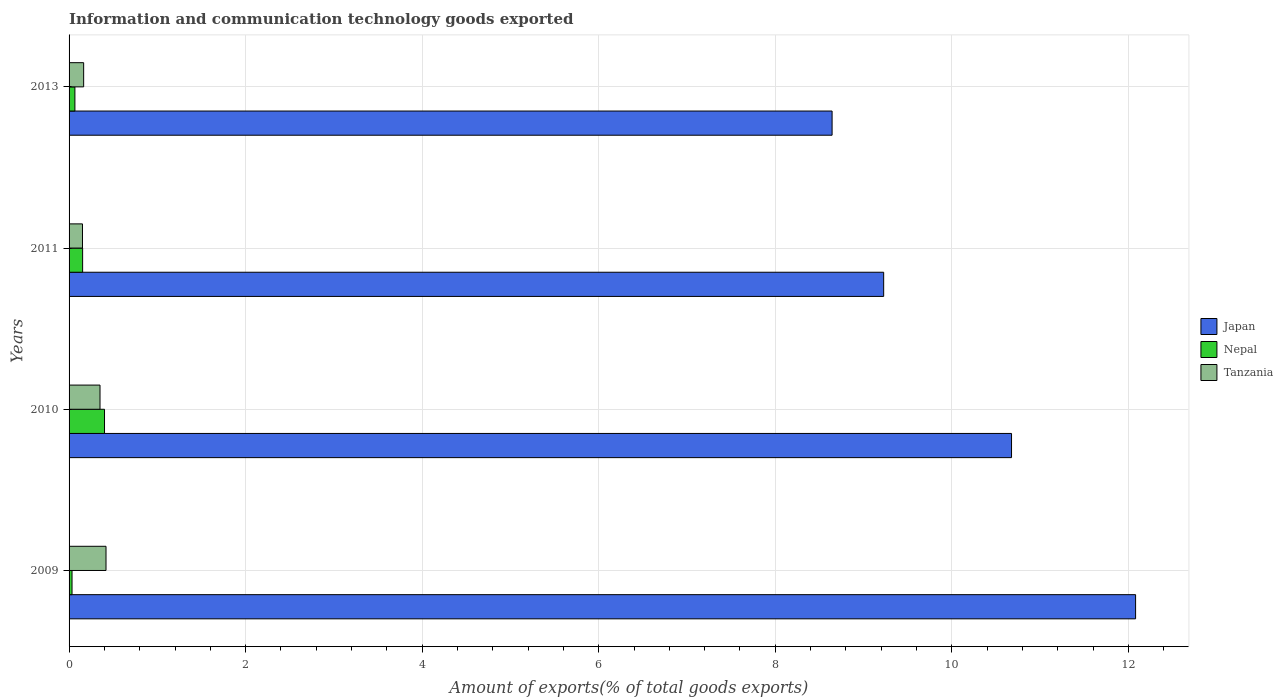How many groups of bars are there?
Provide a succinct answer. 4. Are the number of bars on each tick of the Y-axis equal?
Provide a succinct answer. Yes. How many bars are there on the 3rd tick from the top?
Keep it short and to the point. 3. How many bars are there on the 4th tick from the bottom?
Offer a terse response. 3. In how many cases, is the number of bars for a given year not equal to the number of legend labels?
Make the answer very short. 0. What is the amount of goods exported in Nepal in 2011?
Your answer should be very brief. 0.15. Across all years, what is the maximum amount of goods exported in Tanzania?
Your answer should be very brief. 0.42. Across all years, what is the minimum amount of goods exported in Nepal?
Your answer should be very brief. 0.03. In which year was the amount of goods exported in Tanzania maximum?
Offer a very short reply. 2009. What is the total amount of goods exported in Tanzania in the graph?
Give a very brief answer. 1.09. What is the difference between the amount of goods exported in Japan in 2009 and that in 2013?
Your answer should be compact. 3.44. What is the difference between the amount of goods exported in Japan in 2009 and the amount of goods exported in Nepal in 2011?
Make the answer very short. 11.93. What is the average amount of goods exported in Tanzania per year?
Your answer should be very brief. 0.27. In the year 2011, what is the difference between the amount of goods exported in Tanzania and amount of goods exported in Nepal?
Keep it short and to the point. -0. What is the ratio of the amount of goods exported in Japan in 2010 to that in 2013?
Keep it short and to the point. 1.24. Is the amount of goods exported in Japan in 2009 less than that in 2011?
Offer a terse response. No. What is the difference between the highest and the second highest amount of goods exported in Japan?
Your answer should be very brief. 1.41. What is the difference between the highest and the lowest amount of goods exported in Nepal?
Ensure brevity in your answer.  0.37. What does the 3rd bar from the top in 2010 represents?
Ensure brevity in your answer.  Japan. How many bars are there?
Offer a very short reply. 12. Are the values on the major ticks of X-axis written in scientific E-notation?
Keep it short and to the point. No. Does the graph contain any zero values?
Ensure brevity in your answer.  No. How are the legend labels stacked?
Ensure brevity in your answer.  Vertical. What is the title of the graph?
Your response must be concise. Information and communication technology goods exported. What is the label or title of the X-axis?
Provide a succinct answer. Amount of exports(% of total goods exports). What is the label or title of the Y-axis?
Provide a succinct answer. Years. What is the Amount of exports(% of total goods exports) of Japan in 2009?
Provide a short and direct response. 12.08. What is the Amount of exports(% of total goods exports) of Nepal in 2009?
Offer a very short reply. 0.03. What is the Amount of exports(% of total goods exports) of Tanzania in 2009?
Your answer should be compact. 0.42. What is the Amount of exports(% of total goods exports) in Japan in 2010?
Ensure brevity in your answer.  10.68. What is the Amount of exports(% of total goods exports) in Nepal in 2010?
Your answer should be compact. 0.4. What is the Amount of exports(% of total goods exports) of Tanzania in 2010?
Your answer should be very brief. 0.35. What is the Amount of exports(% of total goods exports) in Japan in 2011?
Offer a terse response. 9.23. What is the Amount of exports(% of total goods exports) in Nepal in 2011?
Your answer should be very brief. 0.15. What is the Amount of exports(% of total goods exports) of Tanzania in 2011?
Provide a succinct answer. 0.15. What is the Amount of exports(% of total goods exports) in Japan in 2013?
Ensure brevity in your answer.  8.64. What is the Amount of exports(% of total goods exports) of Nepal in 2013?
Your answer should be compact. 0.07. What is the Amount of exports(% of total goods exports) of Tanzania in 2013?
Offer a terse response. 0.17. Across all years, what is the maximum Amount of exports(% of total goods exports) in Japan?
Give a very brief answer. 12.08. Across all years, what is the maximum Amount of exports(% of total goods exports) of Nepal?
Provide a succinct answer. 0.4. Across all years, what is the maximum Amount of exports(% of total goods exports) of Tanzania?
Give a very brief answer. 0.42. Across all years, what is the minimum Amount of exports(% of total goods exports) in Japan?
Provide a succinct answer. 8.64. Across all years, what is the minimum Amount of exports(% of total goods exports) of Nepal?
Provide a short and direct response. 0.03. Across all years, what is the minimum Amount of exports(% of total goods exports) in Tanzania?
Provide a short and direct response. 0.15. What is the total Amount of exports(% of total goods exports) in Japan in the graph?
Provide a succinct answer. 40.63. What is the total Amount of exports(% of total goods exports) of Nepal in the graph?
Keep it short and to the point. 0.65. What is the total Amount of exports(% of total goods exports) in Tanzania in the graph?
Provide a succinct answer. 1.09. What is the difference between the Amount of exports(% of total goods exports) in Japan in 2009 and that in 2010?
Your answer should be very brief. 1.41. What is the difference between the Amount of exports(% of total goods exports) in Nepal in 2009 and that in 2010?
Keep it short and to the point. -0.37. What is the difference between the Amount of exports(% of total goods exports) of Tanzania in 2009 and that in 2010?
Ensure brevity in your answer.  0.07. What is the difference between the Amount of exports(% of total goods exports) in Japan in 2009 and that in 2011?
Keep it short and to the point. 2.85. What is the difference between the Amount of exports(% of total goods exports) in Nepal in 2009 and that in 2011?
Your answer should be very brief. -0.12. What is the difference between the Amount of exports(% of total goods exports) of Tanzania in 2009 and that in 2011?
Your answer should be very brief. 0.27. What is the difference between the Amount of exports(% of total goods exports) of Japan in 2009 and that in 2013?
Provide a succinct answer. 3.44. What is the difference between the Amount of exports(% of total goods exports) of Nepal in 2009 and that in 2013?
Keep it short and to the point. -0.03. What is the difference between the Amount of exports(% of total goods exports) of Tanzania in 2009 and that in 2013?
Provide a succinct answer. 0.25. What is the difference between the Amount of exports(% of total goods exports) in Japan in 2010 and that in 2011?
Give a very brief answer. 1.45. What is the difference between the Amount of exports(% of total goods exports) of Nepal in 2010 and that in 2011?
Give a very brief answer. 0.25. What is the difference between the Amount of exports(% of total goods exports) in Tanzania in 2010 and that in 2011?
Your response must be concise. 0.2. What is the difference between the Amount of exports(% of total goods exports) of Japan in 2010 and that in 2013?
Offer a terse response. 2.03. What is the difference between the Amount of exports(% of total goods exports) in Nepal in 2010 and that in 2013?
Offer a very short reply. 0.34. What is the difference between the Amount of exports(% of total goods exports) in Tanzania in 2010 and that in 2013?
Give a very brief answer. 0.19. What is the difference between the Amount of exports(% of total goods exports) in Japan in 2011 and that in 2013?
Give a very brief answer. 0.58. What is the difference between the Amount of exports(% of total goods exports) in Nepal in 2011 and that in 2013?
Offer a terse response. 0.09. What is the difference between the Amount of exports(% of total goods exports) of Tanzania in 2011 and that in 2013?
Make the answer very short. -0.01. What is the difference between the Amount of exports(% of total goods exports) of Japan in 2009 and the Amount of exports(% of total goods exports) of Nepal in 2010?
Offer a terse response. 11.68. What is the difference between the Amount of exports(% of total goods exports) of Japan in 2009 and the Amount of exports(% of total goods exports) of Tanzania in 2010?
Your answer should be very brief. 11.73. What is the difference between the Amount of exports(% of total goods exports) of Nepal in 2009 and the Amount of exports(% of total goods exports) of Tanzania in 2010?
Ensure brevity in your answer.  -0.32. What is the difference between the Amount of exports(% of total goods exports) in Japan in 2009 and the Amount of exports(% of total goods exports) in Nepal in 2011?
Your answer should be very brief. 11.93. What is the difference between the Amount of exports(% of total goods exports) of Japan in 2009 and the Amount of exports(% of total goods exports) of Tanzania in 2011?
Keep it short and to the point. 11.93. What is the difference between the Amount of exports(% of total goods exports) in Nepal in 2009 and the Amount of exports(% of total goods exports) in Tanzania in 2011?
Ensure brevity in your answer.  -0.12. What is the difference between the Amount of exports(% of total goods exports) of Japan in 2009 and the Amount of exports(% of total goods exports) of Nepal in 2013?
Provide a short and direct response. 12.02. What is the difference between the Amount of exports(% of total goods exports) of Japan in 2009 and the Amount of exports(% of total goods exports) of Tanzania in 2013?
Your answer should be compact. 11.92. What is the difference between the Amount of exports(% of total goods exports) in Nepal in 2009 and the Amount of exports(% of total goods exports) in Tanzania in 2013?
Offer a very short reply. -0.13. What is the difference between the Amount of exports(% of total goods exports) of Japan in 2010 and the Amount of exports(% of total goods exports) of Nepal in 2011?
Your answer should be compact. 10.52. What is the difference between the Amount of exports(% of total goods exports) in Japan in 2010 and the Amount of exports(% of total goods exports) in Tanzania in 2011?
Provide a short and direct response. 10.52. What is the difference between the Amount of exports(% of total goods exports) in Nepal in 2010 and the Amount of exports(% of total goods exports) in Tanzania in 2011?
Provide a short and direct response. 0.25. What is the difference between the Amount of exports(% of total goods exports) of Japan in 2010 and the Amount of exports(% of total goods exports) of Nepal in 2013?
Your answer should be compact. 10.61. What is the difference between the Amount of exports(% of total goods exports) of Japan in 2010 and the Amount of exports(% of total goods exports) of Tanzania in 2013?
Give a very brief answer. 10.51. What is the difference between the Amount of exports(% of total goods exports) in Nepal in 2010 and the Amount of exports(% of total goods exports) in Tanzania in 2013?
Your response must be concise. 0.24. What is the difference between the Amount of exports(% of total goods exports) of Japan in 2011 and the Amount of exports(% of total goods exports) of Nepal in 2013?
Offer a terse response. 9.16. What is the difference between the Amount of exports(% of total goods exports) in Japan in 2011 and the Amount of exports(% of total goods exports) in Tanzania in 2013?
Your answer should be very brief. 9.06. What is the difference between the Amount of exports(% of total goods exports) in Nepal in 2011 and the Amount of exports(% of total goods exports) in Tanzania in 2013?
Ensure brevity in your answer.  -0.01. What is the average Amount of exports(% of total goods exports) of Japan per year?
Provide a succinct answer. 10.16. What is the average Amount of exports(% of total goods exports) in Nepal per year?
Provide a short and direct response. 0.16. What is the average Amount of exports(% of total goods exports) of Tanzania per year?
Your answer should be very brief. 0.27. In the year 2009, what is the difference between the Amount of exports(% of total goods exports) in Japan and Amount of exports(% of total goods exports) in Nepal?
Provide a short and direct response. 12.05. In the year 2009, what is the difference between the Amount of exports(% of total goods exports) of Japan and Amount of exports(% of total goods exports) of Tanzania?
Your response must be concise. 11.66. In the year 2009, what is the difference between the Amount of exports(% of total goods exports) in Nepal and Amount of exports(% of total goods exports) in Tanzania?
Give a very brief answer. -0.39. In the year 2010, what is the difference between the Amount of exports(% of total goods exports) in Japan and Amount of exports(% of total goods exports) in Nepal?
Your response must be concise. 10.28. In the year 2010, what is the difference between the Amount of exports(% of total goods exports) in Japan and Amount of exports(% of total goods exports) in Tanzania?
Keep it short and to the point. 10.33. In the year 2010, what is the difference between the Amount of exports(% of total goods exports) of Nepal and Amount of exports(% of total goods exports) of Tanzania?
Your response must be concise. 0.05. In the year 2011, what is the difference between the Amount of exports(% of total goods exports) in Japan and Amount of exports(% of total goods exports) in Nepal?
Your response must be concise. 9.07. In the year 2011, what is the difference between the Amount of exports(% of total goods exports) of Japan and Amount of exports(% of total goods exports) of Tanzania?
Keep it short and to the point. 9.08. In the year 2011, what is the difference between the Amount of exports(% of total goods exports) of Nepal and Amount of exports(% of total goods exports) of Tanzania?
Your answer should be compact. 0. In the year 2013, what is the difference between the Amount of exports(% of total goods exports) in Japan and Amount of exports(% of total goods exports) in Nepal?
Your answer should be compact. 8.58. In the year 2013, what is the difference between the Amount of exports(% of total goods exports) in Japan and Amount of exports(% of total goods exports) in Tanzania?
Keep it short and to the point. 8.48. In the year 2013, what is the difference between the Amount of exports(% of total goods exports) of Nepal and Amount of exports(% of total goods exports) of Tanzania?
Your response must be concise. -0.1. What is the ratio of the Amount of exports(% of total goods exports) in Japan in 2009 to that in 2010?
Your answer should be very brief. 1.13. What is the ratio of the Amount of exports(% of total goods exports) in Nepal in 2009 to that in 2010?
Your answer should be compact. 0.08. What is the ratio of the Amount of exports(% of total goods exports) of Tanzania in 2009 to that in 2010?
Your answer should be very brief. 1.19. What is the ratio of the Amount of exports(% of total goods exports) of Japan in 2009 to that in 2011?
Make the answer very short. 1.31. What is the ratio of the Amount of exports(% of total goods exports) of Nepal in 2009 to that in 2011?
Provide a short and direct response. 0.22. What is the ratio of the Amount of exports(% of total goods exports) of Tanzania in 2009 to that in 2011?
Provide a short and direct response. 2.75. What is the ratio of the Amount of exports(% of total goods exports) in Japan in 2009 to that in 2013?
Your response must be concise. 1.4. What is the ratio of the Amount of exports(% of total goods exports) of Nepal in 2009 to that in 2013?
Ensure brevity in your answer.  0.51. What is the ratio of the Amount of exports(% of total goods exports) in Tanzania in 2009 to that in 2013?
Make the answer very short. 2.53. What is the ratio of the Amount of exports(% of total goods exports) of Japan in 2010 to that in 2011?
Your response must be concise. 1.16. What is the ratio of the Amount of exports(% of total goods exports) of Nepal in 2010 to that in 2011?
Offer a very short reply. 2.62. What is the ratio of the Amount of exports(% of total goods exports) in Tanzania in 2010 to that in 2011?
Give a very brief answer. 2.31. What is the ratio of the Amount of exports(% of total goods exports) of Japan in 2010 to that in 2013?
Keep it short and to the point. 1.24. What is the ratio of the Amount of exports(% of total goods exports) in Nepal in 2010 to that in 2013?
Give a very brief answer. 6.07. What is the ratio of the Amount of exports(% of total goods exports) of Tanzania in 2010 to that in 2013?
Give a very brief answer. 2.12. What is the ratio of the Amount of exports(% of total goods exports) in Japan in 2011 to that in 2013?
Provide a succinct answer. 1.07. What is the ratio of the Amount of exports(% of total goods exports) of Nepal in 2011 to that in 2013?
Offer a very short reply. 2.32. What is the difference between the highest and the second highest Amount of exports(% of total goods exports) in Japan?
Keep it short and to the point. 1.41. What is the difference between the highest and the second highest Amount of exports(% of total goods exports) of Nepal?
Your answer should be very brief. 0.25. What is the difference between the highest and the second highest Amount of exports(% of total goods exports) of Tanzania?
Provide a short and direct response. 0.07. What is the difference between the highest and the lowest Amount of exports(% of total goods exports) in Japan?
Your answer should be very brief. 3.44. What is the difference between the highest and the lowest Amount of exports(% of total goods exports) of Nepal?
Offer a very short reply. 0.37. What is the difference between the highest and the lowest Amount of exports(% of total goods exports) of Tanzania?
Provide a short and direct response. 0.27. 